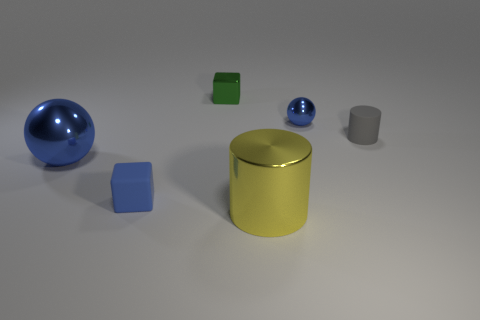What can you infer about the light source in this image? The light source seems to be coming from the upper left side of the image, as indicated by the shadows cast towards the bottom right. This directional light creates highlights on the objects and contributes to the three-dimensional look of the scene. 